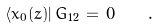<formula> <loc_0><loc_0><loc_500><loc_500>\langle \bar { x } _ { 0 } ( z ) | \, \bar { G } _ { 1 2 } \, = \, 0 \quad .</formula> 